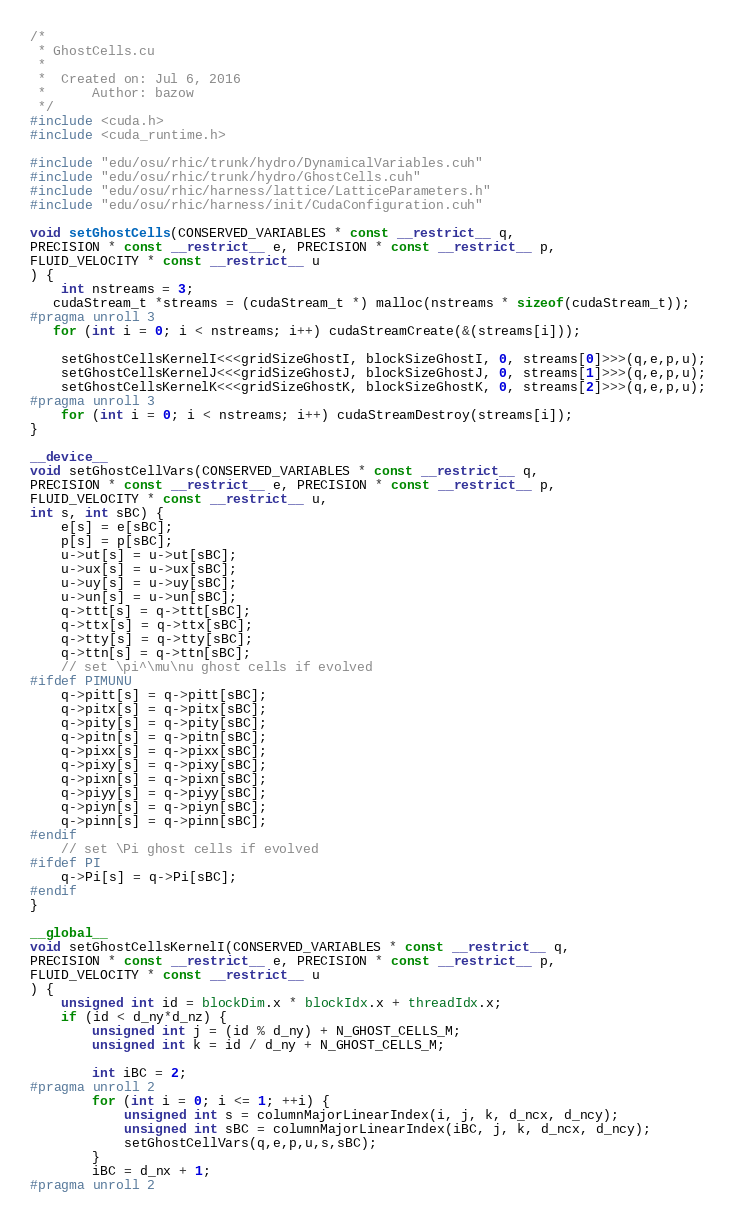Convert code to text. <code><loc_0><loc_0><loc_500><loc_500><_Cuda_>/*
 * GhostCells.cu
 *
 *  Created on: Jul 6, 2016
 *      Author: bazow
 */
#include <cuda.h>
#include <cuda_runtime.h>

#include "edu/osu/rhic/trunk/hydro/DynamicalVariables.cuh"
#include "edu/osu/rhic/trunk/hydro/GhostCells.cuh"
#include "edu/osu/rhic/harness/lattice/LatticeParameters.h"
#include "edu/osu/rhic/harness/init/CudaConfiguration.cuh"

void setGhostCells(CONSERVED_VARIABLES * const __restrict__ q,
PRECISION * const __restrict__ e, PRECISION * const __restrict__ p,
FLUID_VELOCITY * const __restrict__ u
) {
	int nstreams = 3;
   cudaStream_t *streams = (cudaStream_t *) malloc(nstreams * sizeof(cudaStream_t));
#pragma unroll 3
   for (int i = 0; i < nstreams; i++) cudaStreamCreate(&(streams[i]));

	setGhostCellsKernelI<<<gridSizeGhostI, blockSizeGhostI, 0, streams[0]>>>(q,e,p,u);
	setGhostCellsKernelJ<<<gridSizeGhostJ, blockSizeGhostJ, 0, streams[1]>>>(q,e,p,u);
	setGhostCellsKernelK<<<gridSizeGhostK, blockSizeGhostK, 0, streams[2]>>>(q,e,p,u);
#pragma unroll 3
	for (int i = 0; i < nstreams; i++) cudaStreamDestroy(streams[i]);
}

__device__
void setGhostCellVars(CONSERVED_VARIABLES * const __restrict__ q,
PRECISION * const __restrict__ e, PRECISION * const __restrict__ p,
FLUID_VELOCITY * const __restrict__ u,
int s, int sBC) {
	e[s] = e[sBC];
	p[s] = p[sBC];
	u->ut[s] = u->ut[sBC];
	u->ux[s] = u->ux[sBC];
	u->uy[s] = u->uy[sBC];
	u->un[s] = u->un[sBC];
	q->ttt[s] = q->ttt[sBC];
	q->ttx[s] = q->ttx[sBC];
	q->tty[s] = q->tty[sBC];
	q->ttn[s] = q->ttn[sBC];
	// set \pi^\mu\nu ghost cells if evolved
#ifdef PIMUNU
	q->pitt[s] = q->pitt[sBC];
	q->pitx[s] = q->pitx[sBC];
	q->pity[s] = q->pity[sBC];
	q->pitn[s] = q->pitn[sBC];
	q->pixx[s] = q->pixx[sBC];
	q->pixy[s] = q->pixy[sBC];
	q->pixn[s] = q->pixn[sBC];
	q->piyy[s] = q->piyy[sBC];
	q->piyn[s] = q->piyn[sBC];
	q->pinn[s] = q->pinn[sBC];
#endif
	// set \Pi ghost cells if evolved
#ifdef PI
	q->Pi[s] = q->Pi[sBC];
#endif
}

__global__
void setGhostCellsKernelI(CONSERVED_VARIABLES * const __restrict__ q,
PRECISION * const __restrict__ e, PRECISION * const __restrict__ p,
FLUID_VELOCITY * const __restrict__ u
) {
	unsigned int id = blockDim.x * blockIdx.x + threadIdx.x;
	if (id < d_ny*d_nz) {
		unsigned int j = (id % d_ny) + N_GHOST_CELLS_M;
		unsigned int k = id / d_ny + N_GHOST_CELLS_M;

		int iBC = 2;
#pragma unroll 2
		for (int i = 0; i <= 1; ++i) {
			unsigned int s = columnMajorLinearIndex(i, j, k, d_ncx, d_ncy);
			unsigned int sBC = columnMajorLinearIndex(iBC, j, k, d_ncx, d_ncy);
			setGhostCellVars(q,e,p,u,s,sBC);
		}
		iBC = d_nx + 1;
#pragma unroll 2</code> 